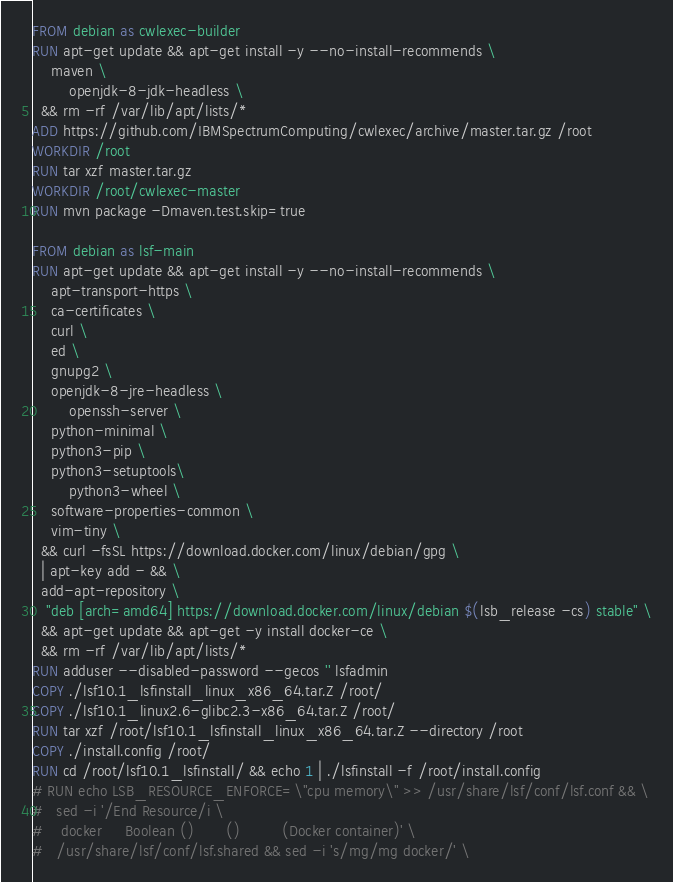Convert code to text. <code><loc_0><loc_0><loc_500><loc_500><_Dockerfile_>FROM debian as cwlexec-builder
RUN apt-get update && apt-get install -y --no-install-recommends \
	maven \
        openjdk-8-jdk-headless \
  && rm -rf /var/lib/apt/lists/*
ADD https://github.com/IBMSpectrumComputing/cwlexec/archive/master.tar.gz /root
WORKDIR /root
RUN tar xzf master.tar.gz
WORKDIR /root/cwlexec-master
RUN mvn package -Dmaven.test.skip=true

FROM debian as lsf-main
RUN apt-get update && apt-get install -y --no-install-recommends \
	apt-transport-https \
	ca-certificates \
	curl \
	ed \
	gnupg2 \
	openjdk-8-jre-headless \
        openssh-server \
	python-minimal \
	python3-pip \
	python3-setuptools\
        python3-wheel \
	software-properties-common \
	vim-tiny \
  && curl -fsSL https://download.docker.com/linux/debian/gpg \
  | apt-key add - && \
  add-apt-repository \
   "deb [arch=amd64] https://download.docker.com/linux/debian $(lsb_release -cs) stable" \
  && apt-get update && apt-get -y install docker-ce \
  && rm -rf /var/lib/apt/lists/*
RUN adduser --disabled-password --gecos '' lsfadmin
COPY ./lsf10.1_lsfinstall_linux_x86_64.tar.Z /root/
COPY ./lsf10.1_linux2.6-glibc2.3-x86_64.tar.Z /root/
RUN tar xzf /root/lsf10.1_lsfinstall_linux_x86_64.tar.Z --directory /root
COPY ./install.config /root/
RUN cd /root/lsf10.1_lsfinstall/ && echo 1 | ./lsfinstall -f /root/install.config
# RUN echo LSB_RESOURCE_ENFORCE=\"cpu memory\" >> /usr/share/lsf/conf/lsf.conf && \
# 	sed -i '/End Resource/i \
#    docker     Boolean ()       ()         (Docker container)' \
# 	/usr/share/lsf/conf/lsf.shared && sed -i 's/mg/mg docker/' \</code> 